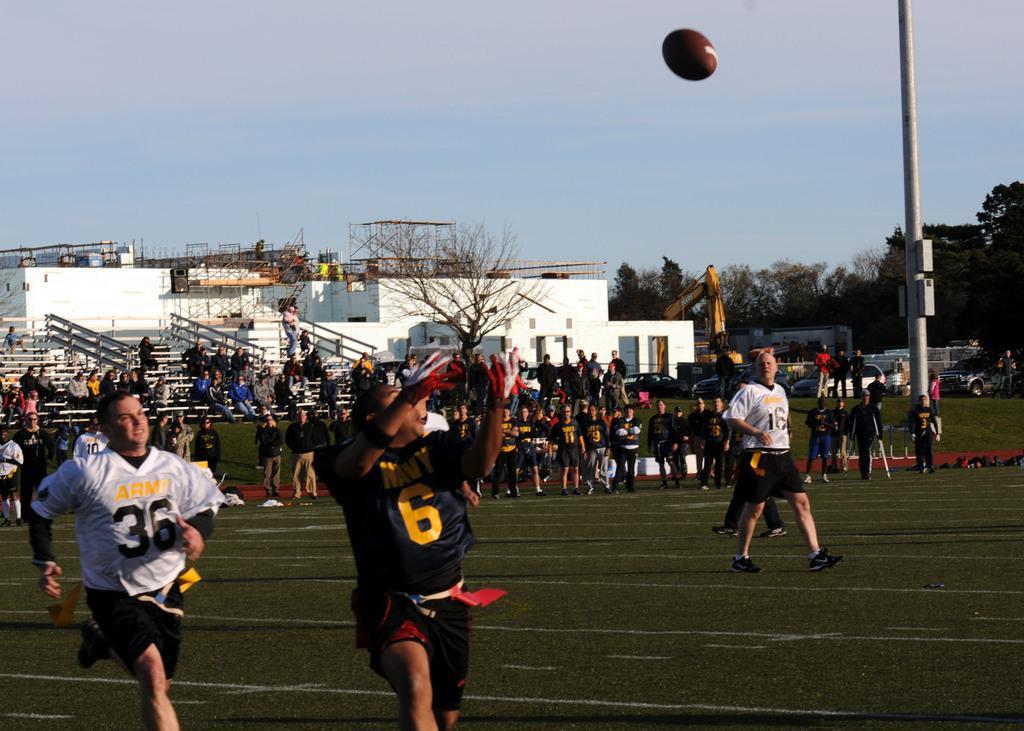Describe this image in one or two sentences. Some people are playing american football. And the ball is in the air. Person in the front is wearing a gloves and is having a number on the t shirt. In the back there are many people. Also there are buildings, trees, seats, railings, sky in the background. Also there is a crane in the back. On the right side there is a pole. Also there are trees and a vehicle on the right side. 